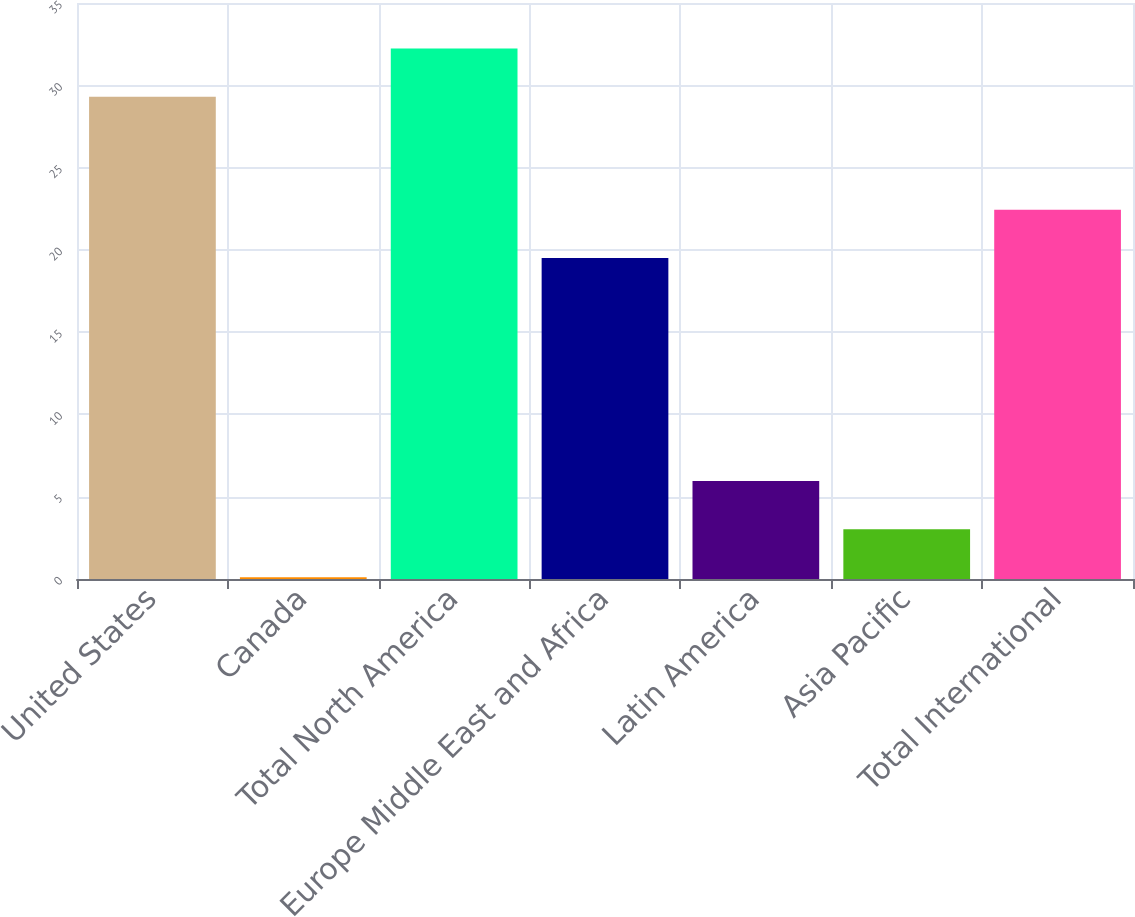Convert chart to OTSL. <chart><loc_0><loc_0><loc_500><loc_500><bar_chart><fcel>United States<fcel>Canada<fcel>Total North America<fcel>Europe Middle East and Africa<fcel>Latin America<fcel>Asia Pacific<fcel>Total International<nl><fcel>29.3<fcel>0.1<fcel>32.23<fcel>19.5<fcel>5.96<fcel>3.03<fcel>22.43<nl></chart> 